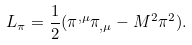<formula> <loc_0><loc_0><loc_500><loc_500>L _ { \pi } = \frac { 1 } { 2 } ( \pi ^ { , \mu } \pi _ { , \mu } - M ^ { 2 } \pi ^ { 2 } ) .</formula> 